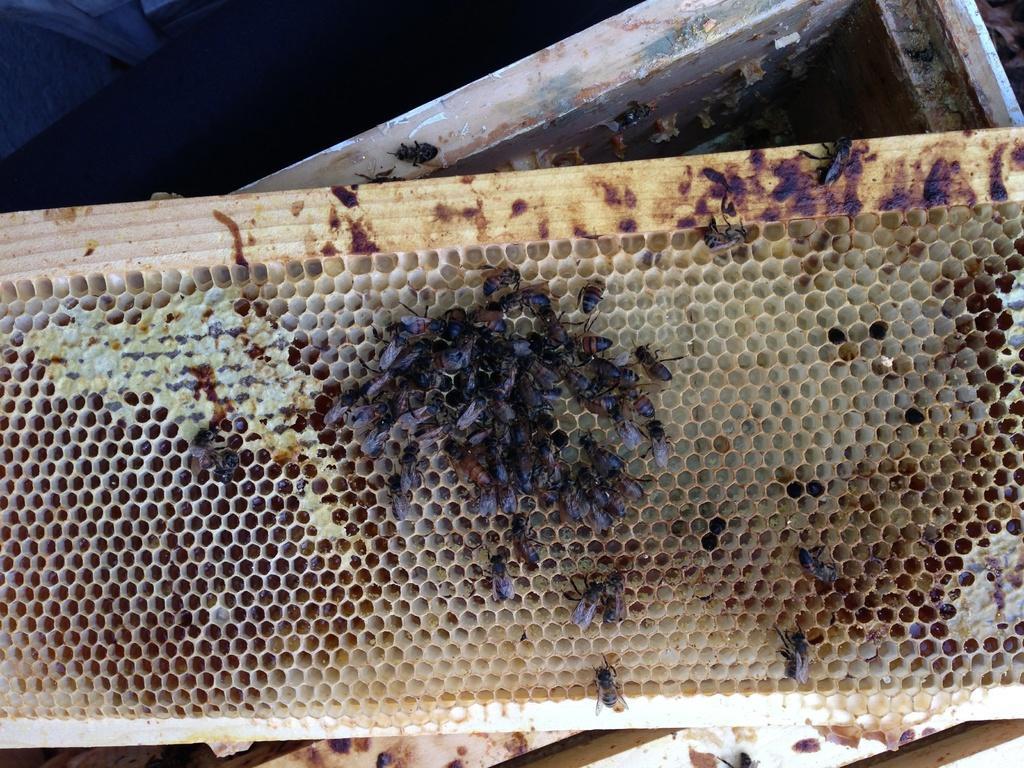Describe this image in one or two sentences. In the picture we can see the honeycomb with group of honey bees on it. 